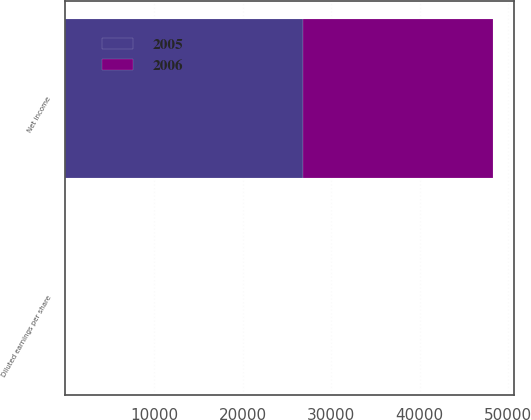Convert chart. <chart><loc_0><loc_0><loc_500><loc_500><stacked_bar_chart><ecel><fcel>Net income<fcel>Diluted earnings per share<nl><fcel>2006<fcel>21446<fcel>0.3<nl><fcel>2005<fcel>26845<fcel>0.38<nl></chart> 